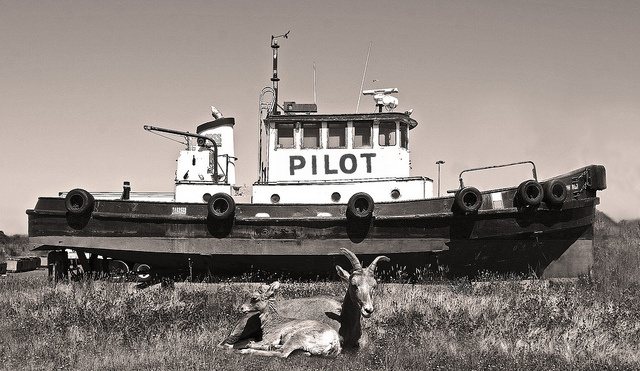Describe the objects in this image and their specific colors. I can see boat in gray, black, white, and darkgray tones and sheep in gray, black, darkgray, and lightgray tones in this image. 